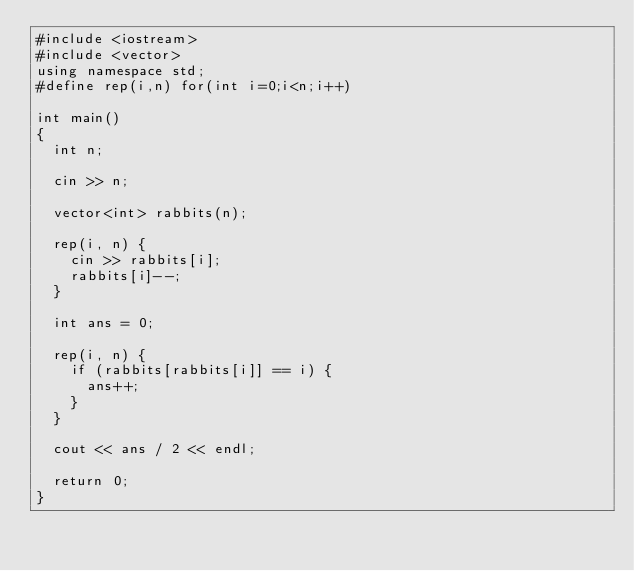<code> <loc_0><loc_0><loc_500><loc_500><_C++_>#include <iostream>
#include <vector>
using namespace std;
#define rep(i,n) for(int i=0;i<n;i++)

int main()
{
	int n;

	cin >> n;

	vector<int> rabbits(n);

	rep(i, n) {
		cin >> rabbits[i];
		rabbits[i]--;
	}

	int ans = 0;

	rep(i, n) {
		if (rabbits[rabbits[i]] == i) {
			ans++;
		}
	}

	cout << ans / 2 << endl;

	return 0;
}</code> 